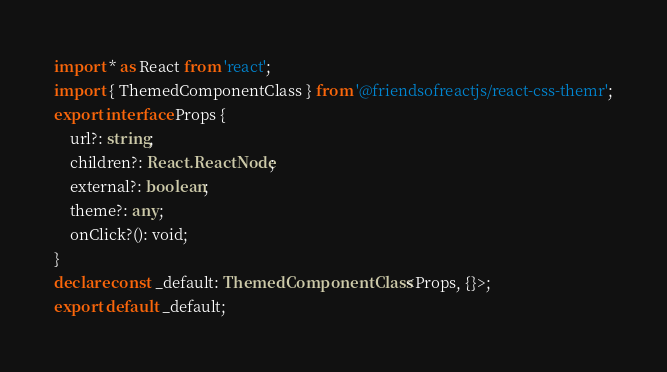<code> <loc_0><loc_0><loc_500><loc_500><_TypeScript_>import * as React from 'react';
import { ThemedComponentClass } from '@friendsofreactjs/react-css-themr';
export interface Props {
    url?: string;
    children?: React.ReactNode;
    external?: boolean;
    theme?: any;
    onClick?(): void;
}
declare const _default: ThemedComponentClass<Props, {}>;
export default _default;
</code> 